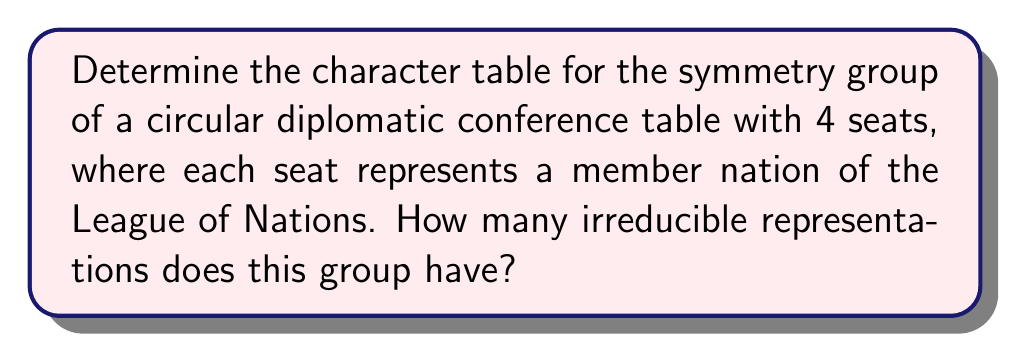What is the answer to this math problem? Let's approach this step-by-step:

1) First, we need to identify the symmetry group. For a circular table with 4 seats, the symmetry group is $D_4$, the dihedral group of order 8.

2) The elements of $D_4$ are:
   - The identity element (e)
   - Three rotations by 90°, 180°, and 270° (r, r², r³)
   - Four reflections (s, sr, sr², sr³)

3) $D_4$ has 5 conjugacy classes:
   {e}, {r, r³}, {r²}, {s, sr²}, {sr, sr³}

4) The number of irreducible representations is equal to the number of conjugacy classes, so there are 5 irreducible representations.

5) To construct the character table, we need to find these 5 irreducible representations:
   - Two 1-dimensional representations: the trivial representation and the sign representation
   - One 2-dimensional representation
   - Two more 1-dimensional representations

6) The character table for $D_4$ is:

$$
\begin{array}{c|ccccc}
D_4 & \{e\} & \{r,r^3\} & \{r^2\} & \{s,sr^2\} & \{sr,sr^3\} \\
\hline
\chi_1 & 1 & 1 & 1 & 1 & 1 \\
\chi_2 & 1 & -1 & 1 & 1 & -1 \\
\chi_3 & 1 & -1 & 1 & -1 & 1 \\
\chi_4 & 1 & 1 & 1 & -1 & -1 \\
\chi_5 & 2 & 0 & -2 & 0 & 0
\end{array}
$$

Here, $\chi_1$ is the trivial representation, $\chi_2$ and $\chi_3$ are the other 1-dimensional representations, $\chi_4$ is the sign representation, and $\chi_5$ is the 2-dimensional representation.
Answer: 5 irreducible representations 